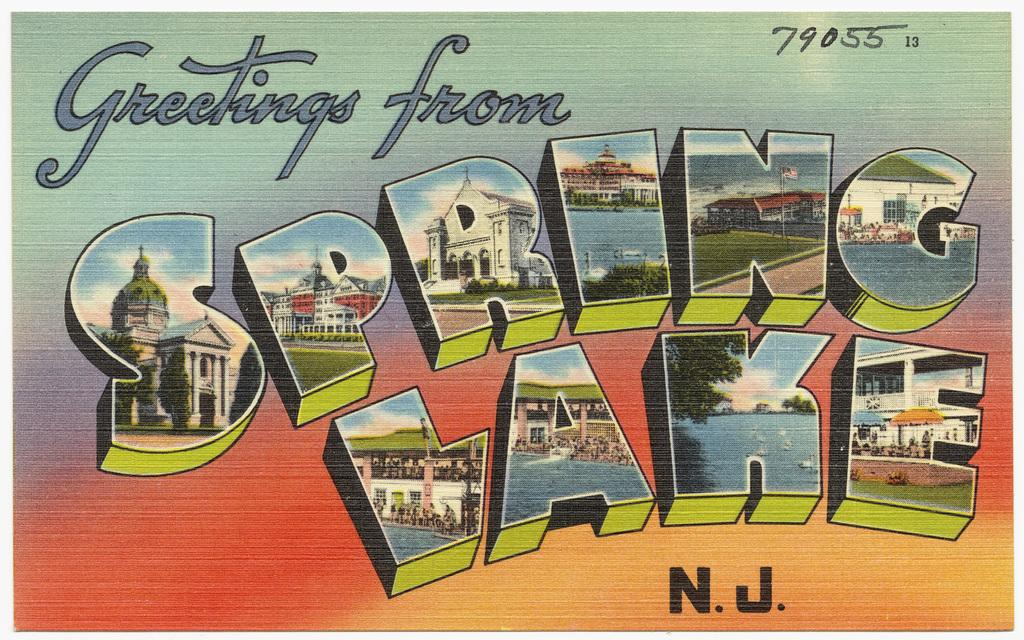What can be found in the image that contains written information? There is text in the image. What type of structures can be seen in the image? There are buildings in the image. What natural element is visible in the image? There is water visible in the image. What is covering the top of one of the structures in the image? There is a roof in the image. What vertical structures can be seen in the image? There are poles in the image. What temporary shelters are present in the image? There are tents in the image. What type of vegetation is visible in the image? There is grass in the image. What is the base surface visible in the image? There is ground visible in the image. What type of trees can be seen in the image? There are trees in the image. What type of rod can be seen holding up the tents in the image? There is no rod holding up the tents in the image; they are supported by poles. What season is depicted in the image, considering the presence of winter clothing? There is no indication of winter clothing or any specific season in the image. What type of corn can be seen growing in the image? There is no corn present in the image. 